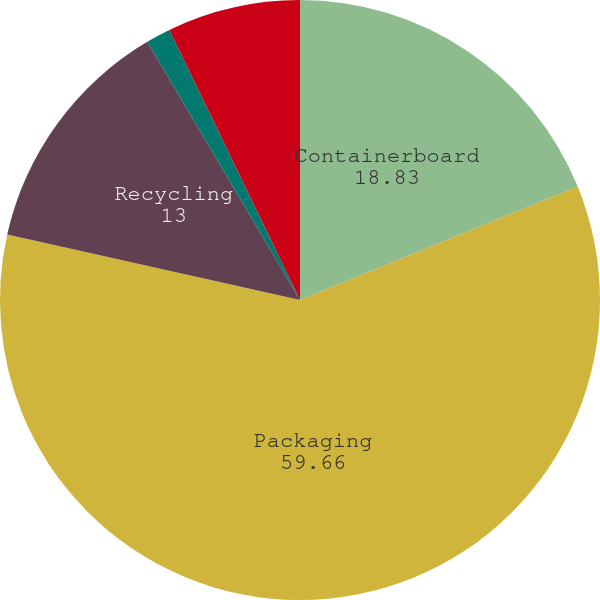Convert chart to OTSL. <chart><loc_0><loc_0><loc_500><loc_500><pie_chart><fcel>Containerboard<fcel>Packaging<fcel>Recycling<fcel>Kraft bags and sacks<fcel>Other products<nl><fcel>18.83%<fcel>59.66%<fcel>13.0%<fcel>1.33%<fcel>7.17%<nl></chart> 